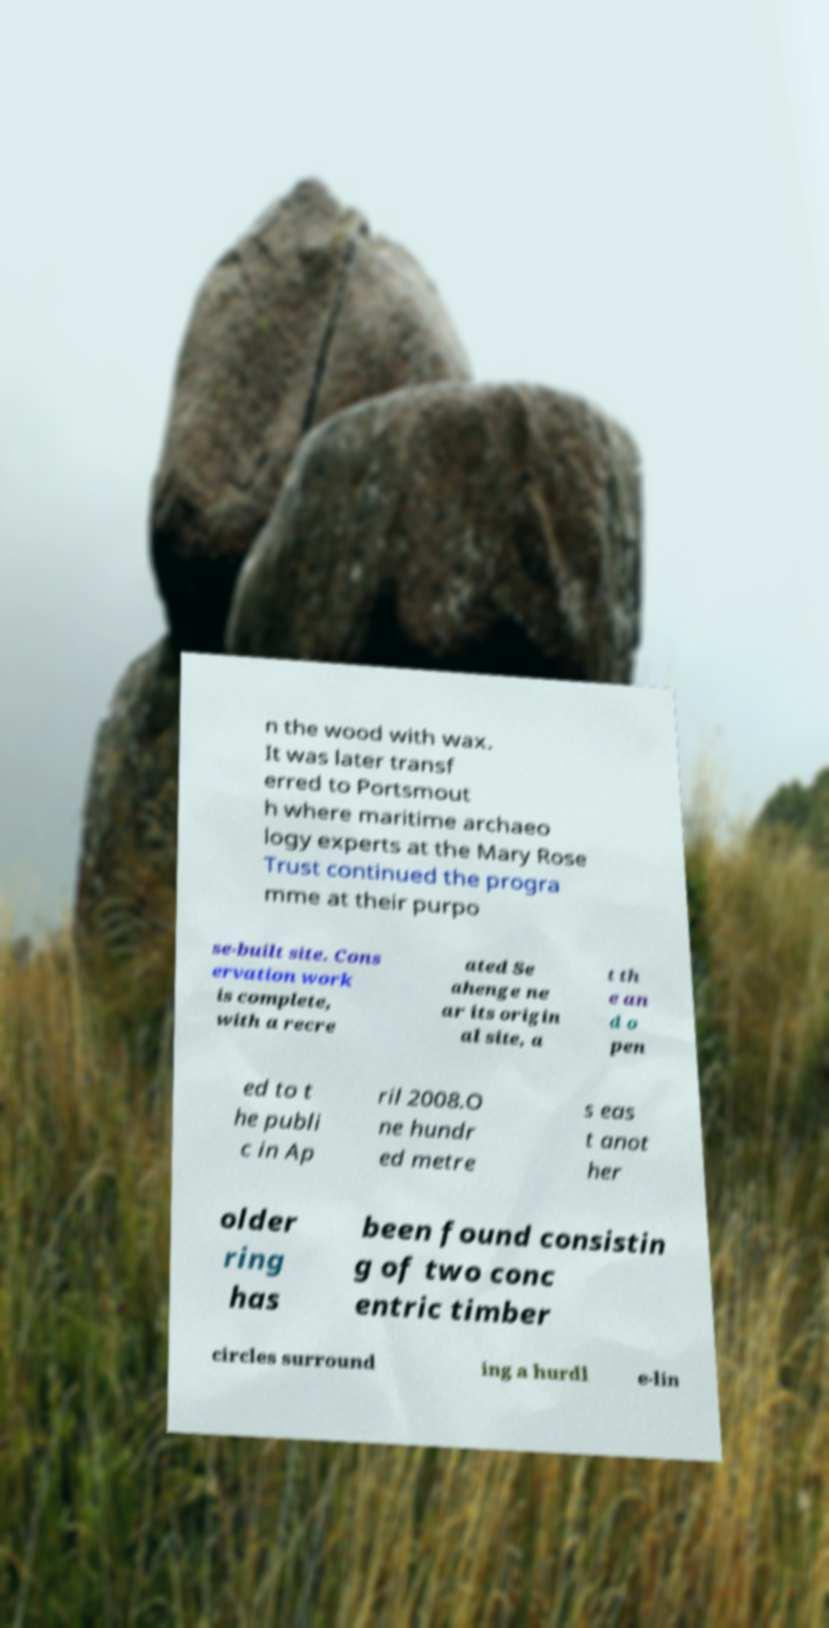Please identify and transcribe the text found in this image. n the wood with wax. It was later transf erred to Portsmout h where maritime archaeo logy experts at the Mary Rose Trust continued the progra mme at their purpo se-built site. Cons ervation work is complete, with a recre ated Se ahenge ne ar its origin al site, a t th e an d o pen ed to t he publi c in Ap ril 2008.O ne hundr ed metre s eas t anot her older ring has been found consistin g of two conc entric timber circles surround ing a hurdl e-lin 